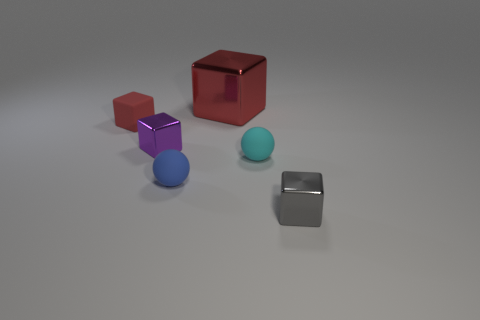What number of large things are green blocks or rubber spheres?
Ensure brevity in your answer.  0. There is another block that is the same color as the matte cube; what is its material?
Make the answer very short. Metal. Is the material of the tiny sphere right of the blue object the same as the thing that is in front of the blue thing?
Provide a succinct answer. No. Is there a big gray metallic block?
Give a very brief answer. No. Is the number of tiny purple cubes behind the small blue ball greater than the number of red rubber cubes in front of the small purple metallic object?
Give a very brief answer. Yes. There is another big object that is the same shape as the purple thing; what material is it?
Provide a succinct answer. Metal. Is there any other thing that is the same size as the cyan rubber ball?
Keep it short and to the point. Yes. There is a tiny metal object that is in front of the cyan rubber sphere; is it the same color as the tiny matte object in front of the tiny cyan sphere?
Offer a very short reply. No. What is the shape of the gray object?
Make the answer very short. Cube. Are there more purple cubes on the right side of the red shiny block than big purple shiny cylinders?
Your answer should be compact. No. 